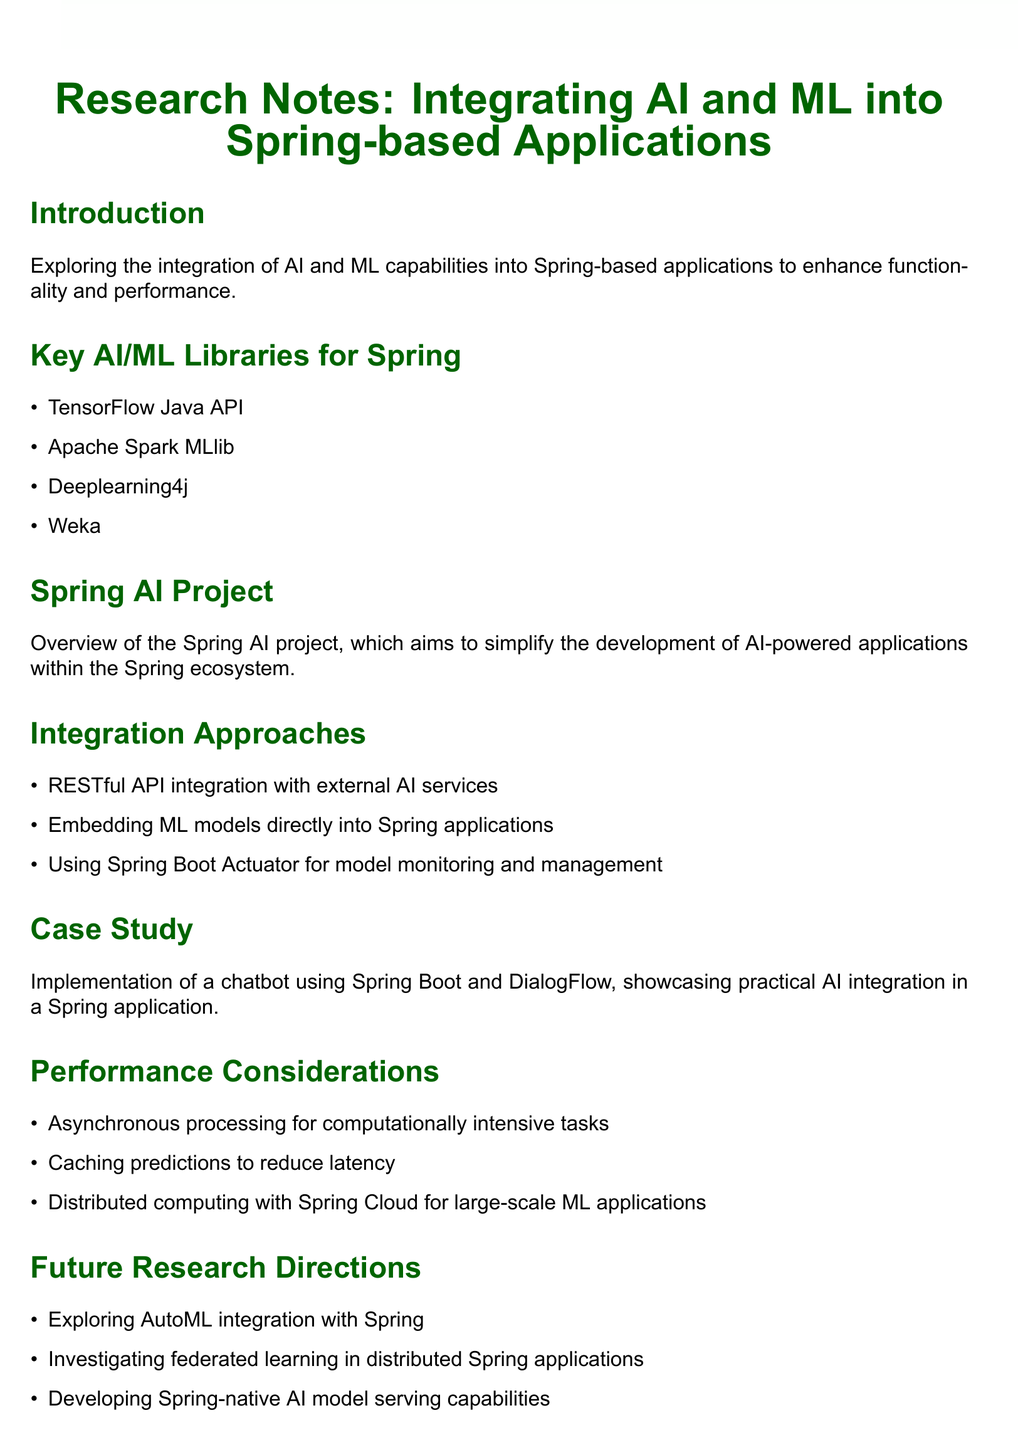What is the title of the document? The title is presented at the top of the document, indicating the subject matter of the notes.
Answer: Research Notes: Integrating AI and ML into Spring-based Applications What is one key AI/ML library mentioned? The document lists several libraries in the section dedicated to key AI/ML libraries for Spring, providing specific names for reference.
Answer: TensorFlow Java API What integration approach uses external AI services? The document outlines multiple approaches for integration, one of which specifically mentions the use of external services.
Answer: RESTful API integration What is the main aim of the Spring AI project? The document gives a brief overview describing the focus of the Spring AI project, which guides the integration process.
Answer: Simplify the development of AI-powered applications What is one future research direction mentioned? The document highlights potential areas for future exploration, which includes specific advancement goals within the field.
Answer: Exploring AutoML integration with Spring What performance consideration is mentioned for large-scale ML applications? The document addresses performance aspects that are crucial for handling intensive tasks in ML applications, including specific techniques to improve efficiency.
Answer: Distributed computing with Spring Cloud What case study is presented in the document? The case study section provides a concrete example of AI application within a Spring environment, showcasing practical use.
Answer: Implementation of a chatbot using Spring Boot and DialogFlow What type of processing is suggested for computationally intensive tasks? The notes provide a recommendation relating specifically to how to manage resource-heavy tasks effectively.
Answer: Asynchronous processing How many key AI/ML libraries are listed? The number of items in the corresponding section indicates how many libraries are highlighted for Spring integration.
Answer: Four 